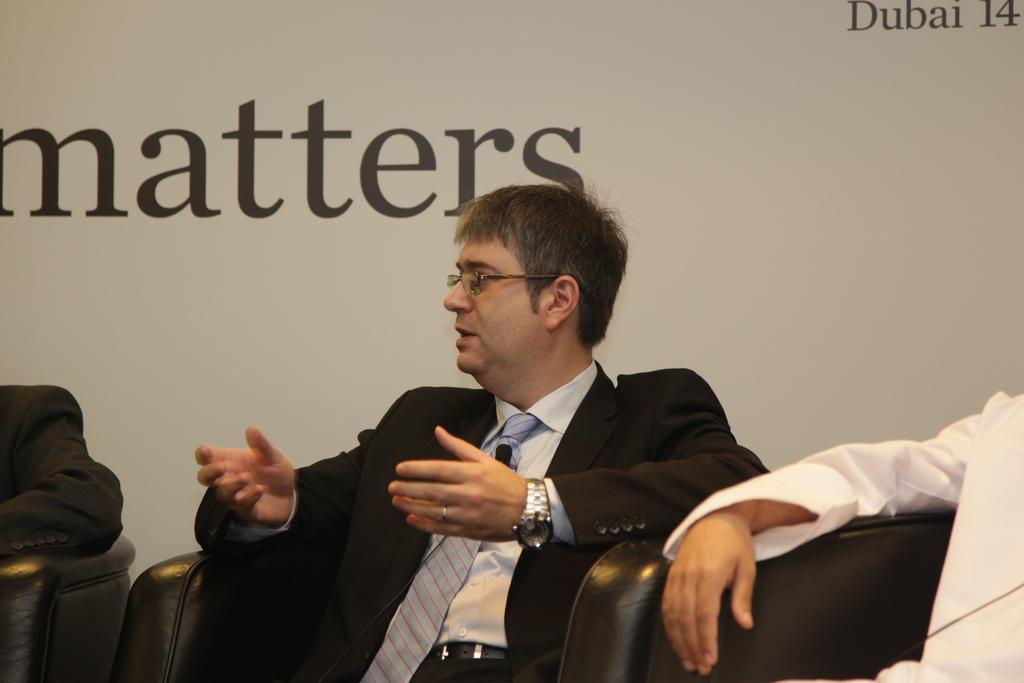Could you give a brief overview of what you see in this image? In this picture we can see three persons sitting on chair and in middle men wore blazer, spectacle, tie, watch and he is talking and in the background we can see wall. 